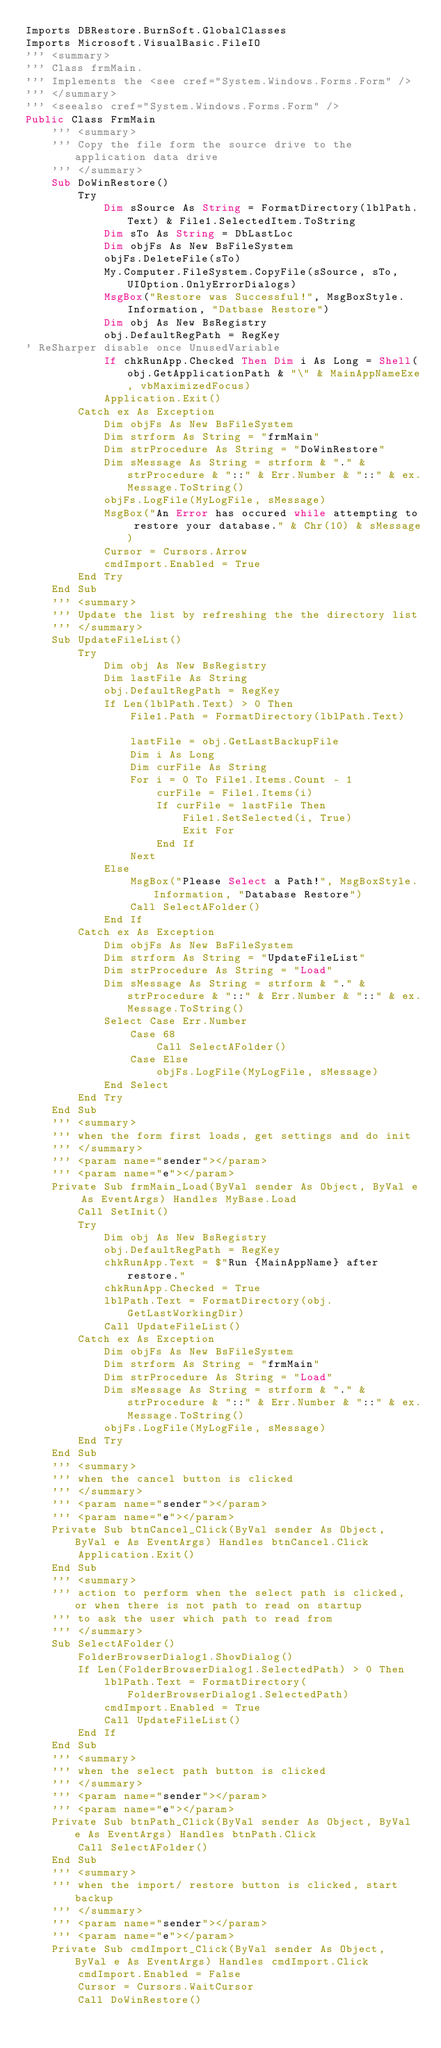Convert code to text. <code><loc_0><loc_0><loc_500><loc_500><_VisualBasic_>Imports DBRestore.BurnSoft.GlobalClasses
Imports Microsoft.VisualBasic.FileIO
''' <summary>
''' Class frmMain.
''' Implements the <see cref="System.Windows.Forms.Form" />
''' </summary>
''' <seealso cref="System.Windows.Forms.Form" />
Public Class FrmMain
    ''' <summary>
    ''' Copy the file form the source drive to the application data drive
    ''' </summary>
    Sub DoWinRestore()
        Try
            Dim sSource As String = FormatDirectory(lblPath.Text) & File1.SelectedItem.ToString
            Dim sTo As String = DbLastLoc
            Dim objFs As New BsFileSystem
            objFs.DeleteFile(sTo)
            My.Computer.FileSystem.CopyFile(sSource, sTo, UIOption.OnlyErrorDialogs)
            MsgBox("Restore was Successful!", MsgBoxStyle.Information, "Datbase Restore")
            Dim obj As New BsRegistry
            obj.DefaultRegPath = RegKey
' ReSharper disable once UnusedVariable
            If chkRunApp.Checked Then Dim i As Long = Shell(obj.GetApplicationPath & "\" & MainAppNameExe, vbMaximizedFocus)
            Application.Exit()
        Catch ex As Exception
            Dim objFs As New BsFileSystem
            Dim strform As String = "frmMain"
            Dim strProcedure As String = "DoWinRestore"
            Dim sMessage As String = strform & "." & strProcedure & "::" & Err.Number & "::" & ex.Message.ToString()
            objFs.LogFile(MyLogFile, sMessage)
            MsgBox("An Error has occured while attempting to restore your database." & Chr(10) & sMessage)
            Cursor = Cursors.Arrow
            cmdImport.Enabled = True
        End Try
    End Sub
    ''' <summary>
    ''' Update the list by refreshing the the directory list
    ''' </summary>
    Sub UpdateFileList()
        Try
            Dim obj As New BsRegistry
            Dim lastFile As String
            obj.DefaultRegPath = RegKey
            If Len(lblPath.Text) > 0 Then
                File1.Path = FormatDirectory(lblPath.Text)

                lastFile = obj.GetLastBackupFile
                Dim i As Long
                Dim curFile As String 
                For i = 0 To File1.Items.Count - 1
                    curFile = File1.Items(i)
                    If curFile = lastFile Then
                        File1.SetSelected(i, True)
                        Exit For
                    End If
                Next
            Else
                MsgBox("Please Select a Path!", MsgBoxStyle.Information, "Database Restore")
                Call SelectAFolder()
            End If
        Catch ex As Exception
            Dim objFs As New BsFileSystem
            Dim strform As String = "UpdateFileList"
            Dim strProcedure As String = "Load"
            Dim sMessage As String = strform & "." & strProcedure & "::" & Err.Number & "::" & ex.Message.ToString()
            Select Case Err.Number
                Case 68
                    Call SelectAFolder()
                Case Else
                    objFs.LogFile(MyLogFile, sMessage)
            End Select
        End Try
    End Sub
    ''' <summary>
    ''' when the form first loads, get settings and do init
    ''' </summary>
    ''' <param name="sender"></param>
    ''' <param name="e"></param>
    Private Sub frmMain_Load(ByVal sender As Object, ByVal e As EventArgs) Handles MyBase.Load
        Call SetInit()
        Try
            Dim obj As New BsRegistry
            obj.DefaultRegPath = RegKey
            chkRunApp.Text = $"Run {MainAppName} after restore."
            chkRunApp.Checked = True
            lblPath.Text = FormatDirectory(obj.GetLastWorkingDir)
            Call UpdateFileList()
        Catch ex As Exception
            Dim objFs As New BsFileSystem
            Dim strform As String = "frmMain"
            Dim strProcedure As String = "Load"
            Dim sMessage As String = strform & "." & strProcedure & "::" & Err.Number & "::" & ex.Message.ToString()
            objFs.LogFile(MyLogFile, sMessage)
        End Try
    End Sub
    ''' <summary>
    ''' when the cancel button is clicked
    ''' </summary>
    ''' <param name="sender"></param>
    ''' <param name="e"></param>
    Private Sub btnCancel_Click(ByVal sender As Object, ByVal e As EventArgs) Handles btnCancel.Click
        Application.Exit()
    End Sub
    ''' <summary>
    ''' action to perform when the select path is clicked, or when there is not path to read on startup
    ''' to ask the user which path to read from
    ''' </summary>
    Sub SelectAFolder()
        FolderBrowserDialog1.ShowDialog()
        If Len(FolderBrowserDialog1.SelectedPath) > 0 Then
            lblPath.Text = FormatDirectory(FolderBrowserDialog1.SelectedPath)
            cmdImport.Enabled = True
            Call UpdateFileList()
        End If
    End Sub
    ''' <summary>
    ''' when the select path button is clicked
    ''' </summary>
    ''' <param name="sender"></param>
    ''' <param name="e"></param>
    Private Sub btnPath_Click(ByVal sender As Object, ByVal e As EventArgs) Handles btnPath.Click
        Call SelectAFolder()
    End Sub
    ''' <summary>
    ''' when the import/ restore button is clicked, start backup
    ''' </summary>
    ''' <param name="sender"></param>
    ''' <param name="e"></param>
    Private Sub cmdImport_Click(ByVal sender As Object, ByVal e As EventArgs) Handles cmdImport.Click
        cmdImport.Enabled = False
        Cursor = Cursors.WaitCursor
        Call DoWinRestore()</code> 